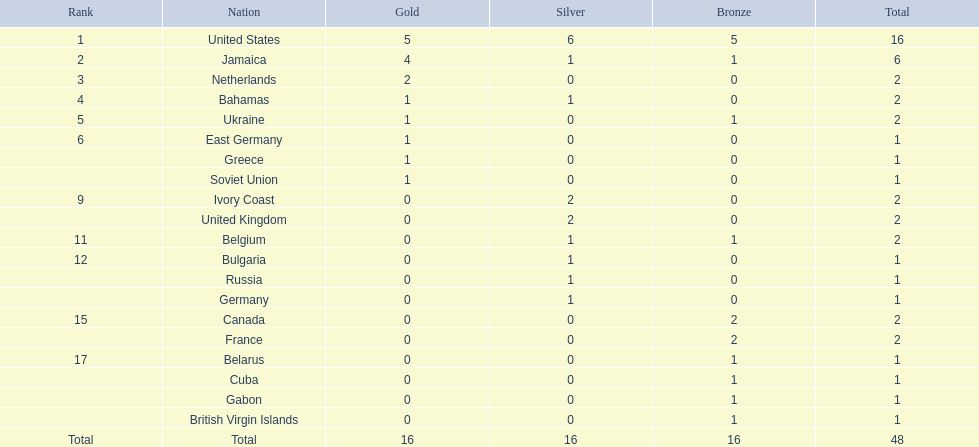What was the highest amount of medals achieved by any nation? 16. Which nation obtained that many medals? United States. 